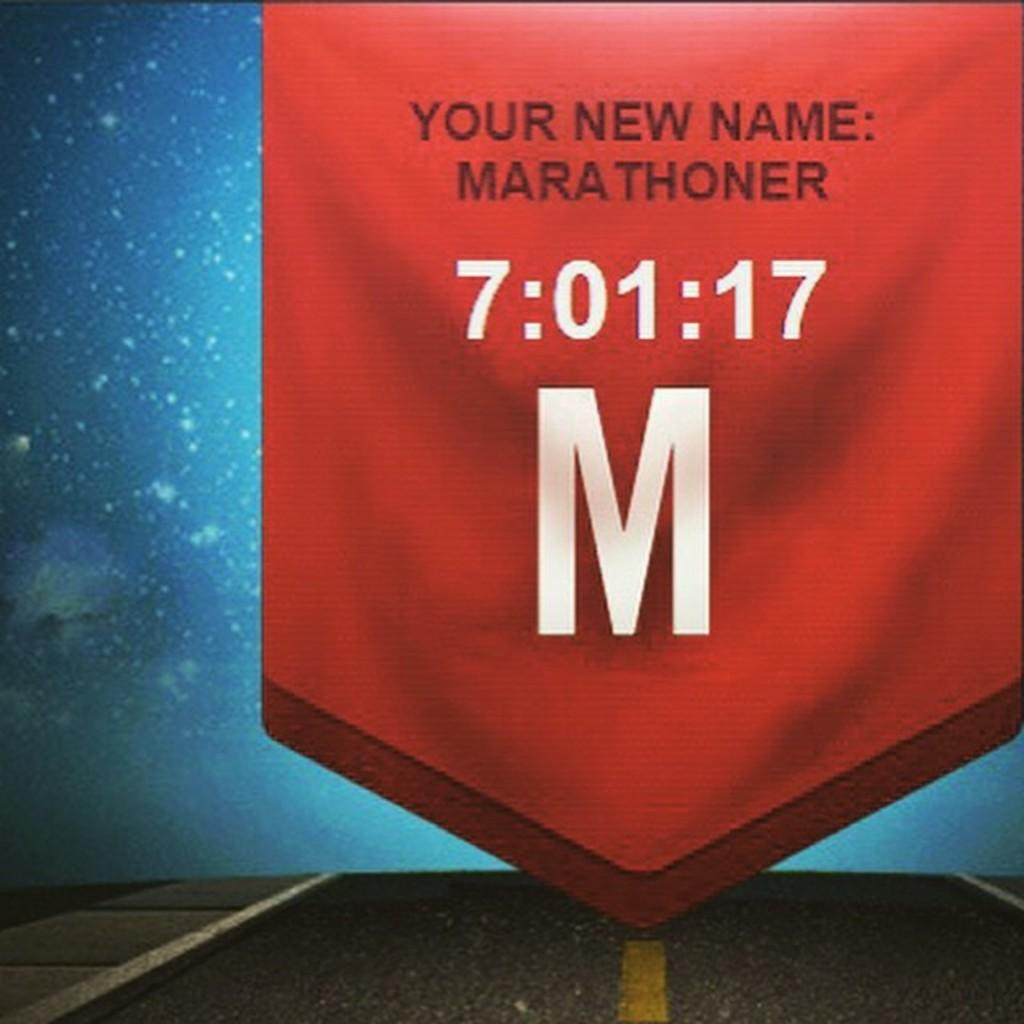Provide a one-sentence caption for the provided image. A red banner that says "Your new name: Marathoner,  7:01:1, M" Is displayed. 